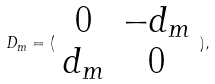Convert formula to latex. <formula><loc_0><loc_0><loc_500><loc_500>D _ { m } = ( \begin{array} { c c } 0 & - d _ { m } \\ d _ { m } & 0 \end{array} ) ,</formula> 